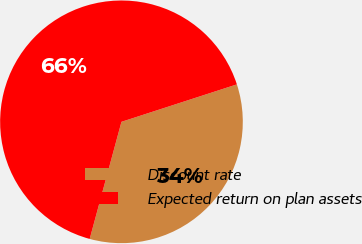Convert chart to OTSL. <chart><loc_0><loc_0><loc_500><loc_500><pie_chart><fcel>Discount rate<fcel>Expected return on plan assets<nl><fcel>34.21%<fcel>65.79%<nl></chart> 